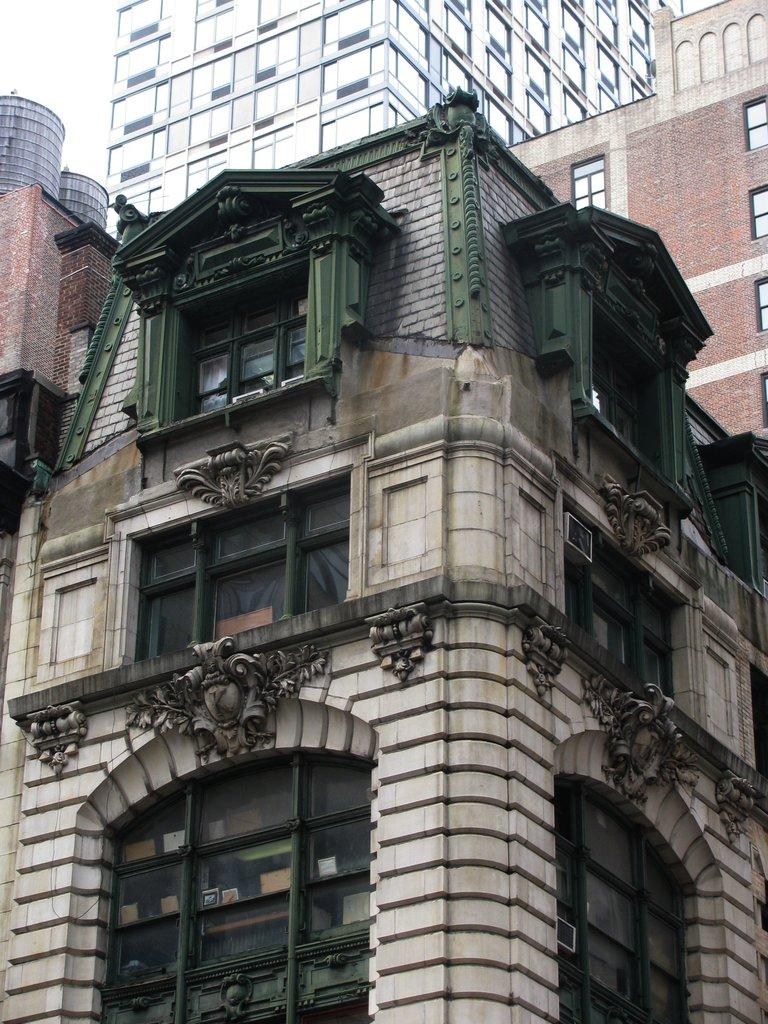What is the main subject in the middle of the image? There is a building in the middle of the image. Can you describe the surroundings of the main building? There are other buildings in the background of the image. What is the price of the yard in the image? There is no yard present in the image, and therefore no price can be determined. 